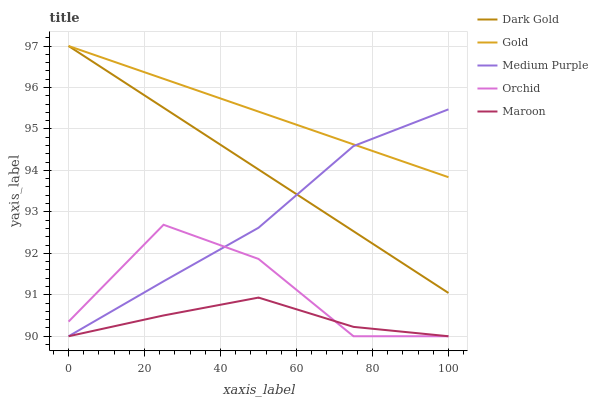Does Maroon have the minimum area under the curve?
Answer yes or no. Yes. Does Gold have the maximum area under the curve?
Answer yes or no. Yes. Does Orchid have the minimum area under the curve?
Answer yes or no. No. Does Orchid have the maximum area under the curve?
Answer yes or no. No. Is Gold the smoothest?
Answer yes or no. Yes. Is Orchid the roughest?
Answer yes or no. Yes. Is Maroon the smoothest?
Answer yes or no. No. Is Maroon the roughest?
Answer yes or no. No. Does Medium Purple have the lowest value?
Answer yes or no. Yes. Does Gold have the lowest value?
Answer yes or no. No. Does Dark Gold have the highest value?
Answer yes or no. Yes. Does Orchid have the highest value?
Answer yes or no. No. Is Maroon less than Dark Gold?
Answer yes or no. Yes. Is Gold greater than Maroon?
Answer yes or no. Yes. Does Dark Gold intersect Medium Purple?
Answer yes or no. Yes. Is Dark Gold less than Medium Purple?
Answer yes or no. No. Is Dark Gold greater than Medium Purple?
Answer yes or no. No. Does Maroon intersect Dark Gold?
Answer yes or no. No. 